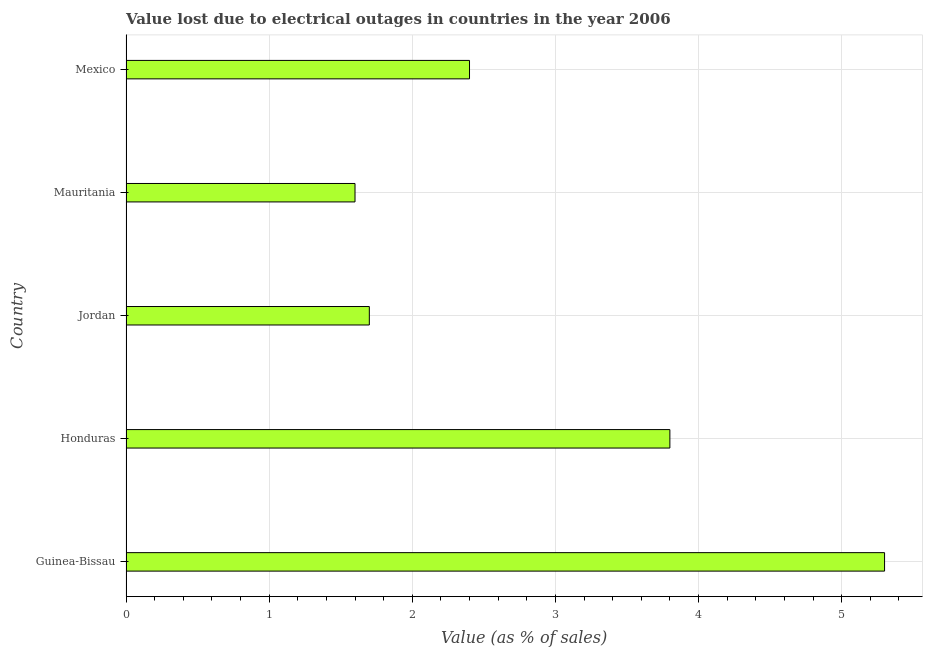Does the graph contain grids?
Your answer should be very brief. Yes. What is the title of the graph?
Offer a very short reply. Value lost due to electrical outages in countries in the year 2006. What is the label or title of the X-axis?
Provide a succinct answer. Value (as % of sales). What is the label or title of the Y-axis?
Provide a short and direct response. Country. What is the value lost due to electrical outages in Mexico?
Your answer should be compact. 2.4. Across all countries, what is the minimum value lost due to electrical outages?
Provide a succinct answer. 1.6. In which country was the value lost due to electrical outages maximum?
Offer a very short reply. Guinea-Bissau. In which country was the value lost due to electrical outages minimum?
Your answer should be compact. Mauritania. What is the sum of the value lost due to electrical outages?
Your answer should be compact. 14.8. What is the average value lost due to electrical outages per country?
Your answer should be compact. 2.96. What is the median value lost due to electrical outages?
Offer a very short reply. 2.4. What is the ratio of the value lost due to electrical outages in Guinea-Bissau to that in Jordan?
Give a very brief answer. 3.12. Is the sum of the value lost due to electrical outages in Mauritania and Mexico greater than the maximum value lost due to electrical outages across all countries?
Your response must be concise. No. What is the difference between two consecutive major ticks on the X-axis?
Offer a terse response. 1. What is the Value (as % of sales) of Mauritania?
Ensure brevity in your answer.  1.6. What is the difference between the Value (as % of sales) in Guinea-Bissau and Jordan?
Provide a succinct answer. 3.6. What is the difference between the Value (as % of sales) in Guinea-Bissau and Mauritania?
Keep it short and to the point. 3.7. What is the difference between the Value (as % of sales) in Honduras and Jordan?
Your answer should be very brief. 2.1. What is the difference between the Value (as % of sales) in Honduras and Mauritania?
Offer a terse response. 2.2. What is the difference between the Value (as % of sales) in Jordan and Mauritania?
Your answer should be compact. 0.1. What is the difference between the Value (as % of sales) in Jordan and Mexico?
Your answer should be compact. -0.7. What is the ratio of the Value (as % of sales) in Guinea-Bissau to that in Honduras?
Provide a succinct answer. 1.4. What is the ratio of the Value (as % of sales) in Guinea-Bissau to that in Jordan?
Ensure brevity in your answer.  3.12. What is the ratio of the Value (as % of sales) in Guinea-Bissau to that in Mauritania?
Provide a succinct answer. 3.31. What is the ratio of the Value (as % of sales) in Guinea-Bissau to that in Mexico?
Provide a succinct answer. 2.21. What is the ratio of the Value (as % of sales) in Honduras to that in Jordan?
Your response must be concise. 2.23. What is the ratio of the Value (as % of sales) in Honduras to that in Mauritania?
Offer a terse response. 2.38. What is the ratio of the Value (as % of sales) in Honduras to that in Mexico?
Offer a very short reply. 1.58. What is the ratio of the Value (as % of sales) in Jordan to that in Mauritania?
Offer a very short reply. 1.06. What is the ratio of the Value (as % of sales) in Jordan to that in Mexico?
Offer a terse response. 0.71. What is the ratio of the Value (as % of sales) in Mauritania to that in Mexico?
Your answer should be very brief. 0.67. 